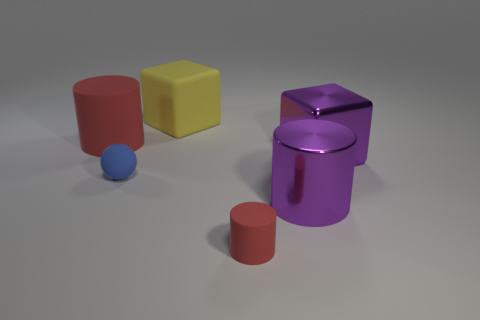What number of other things are the same shape as the yellow rubber object?
Your answer should be very brief. 1. What color is the shiny cylinder that is the same size as the metal cube?
Make the answer very short. Purple. There is a small thing behind the small rubber object that is to the right of the yellow matte thing that is to the right of the blue rubber object; what is its color?
Keep it short and to the point. Blue. There is a blue matte object; is its size the same as the red rubber cylinder left of the small red cylinder?
Offer a very short reply. No. What number of things are large yellow things or large red metal things?
Keep it short and to the point. 1. Are there any small gray balls that have the same material as the large yellow cube?
Ensure brevity in your answer.  No. What size is the object that is the same color as the large metallic cube?
Your answer should be very brief. Large. There is a matte ball that is in front of the large cube that is in front of the large red matte object; what is its color?
Your answer should be very brief. Blue. Do the sphere and the yellow object have the same size?
Provide a succinct answer. No. How many spheres are either tiny brown metal objects or purple metallic objects?
Keep it short and to the point. 0. 